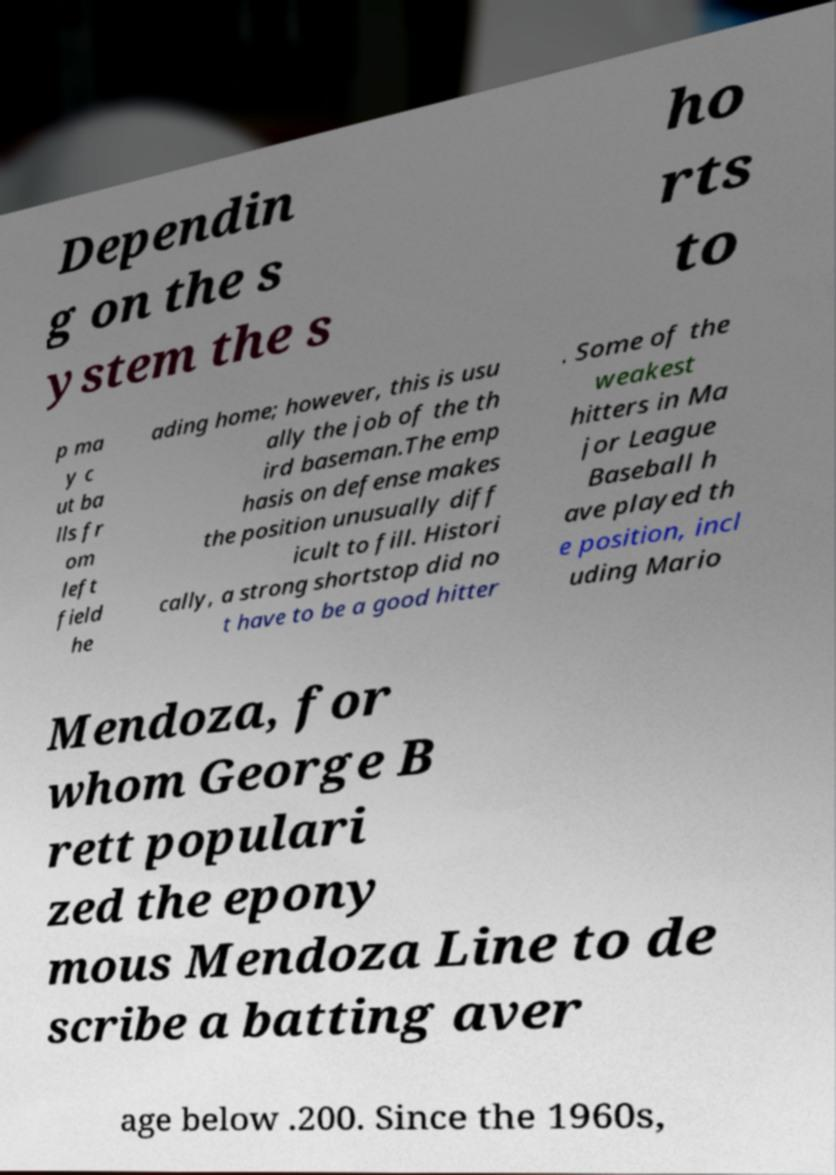For documentation purposes, I need the text within this image transcribed. Could you provide that? Dependin g on the s ystem the s ho rts to p ma y c ut ba lls fr om left field he ading home; however, this is usu ally the job of the th ird baseman.The emp hasis on defense makes the position unusually diff icult to fill. Histori cally, a strong shortstop did no t have to be a good hitter . Some of the weakest hitters in Ma jor League Baseball h ave played th e position, incl uding Mario Mendoza, for whom George B rett populari zed the epony mous Mendoza Line to de scribe a batting aver age below .200. Since the 1960s, 